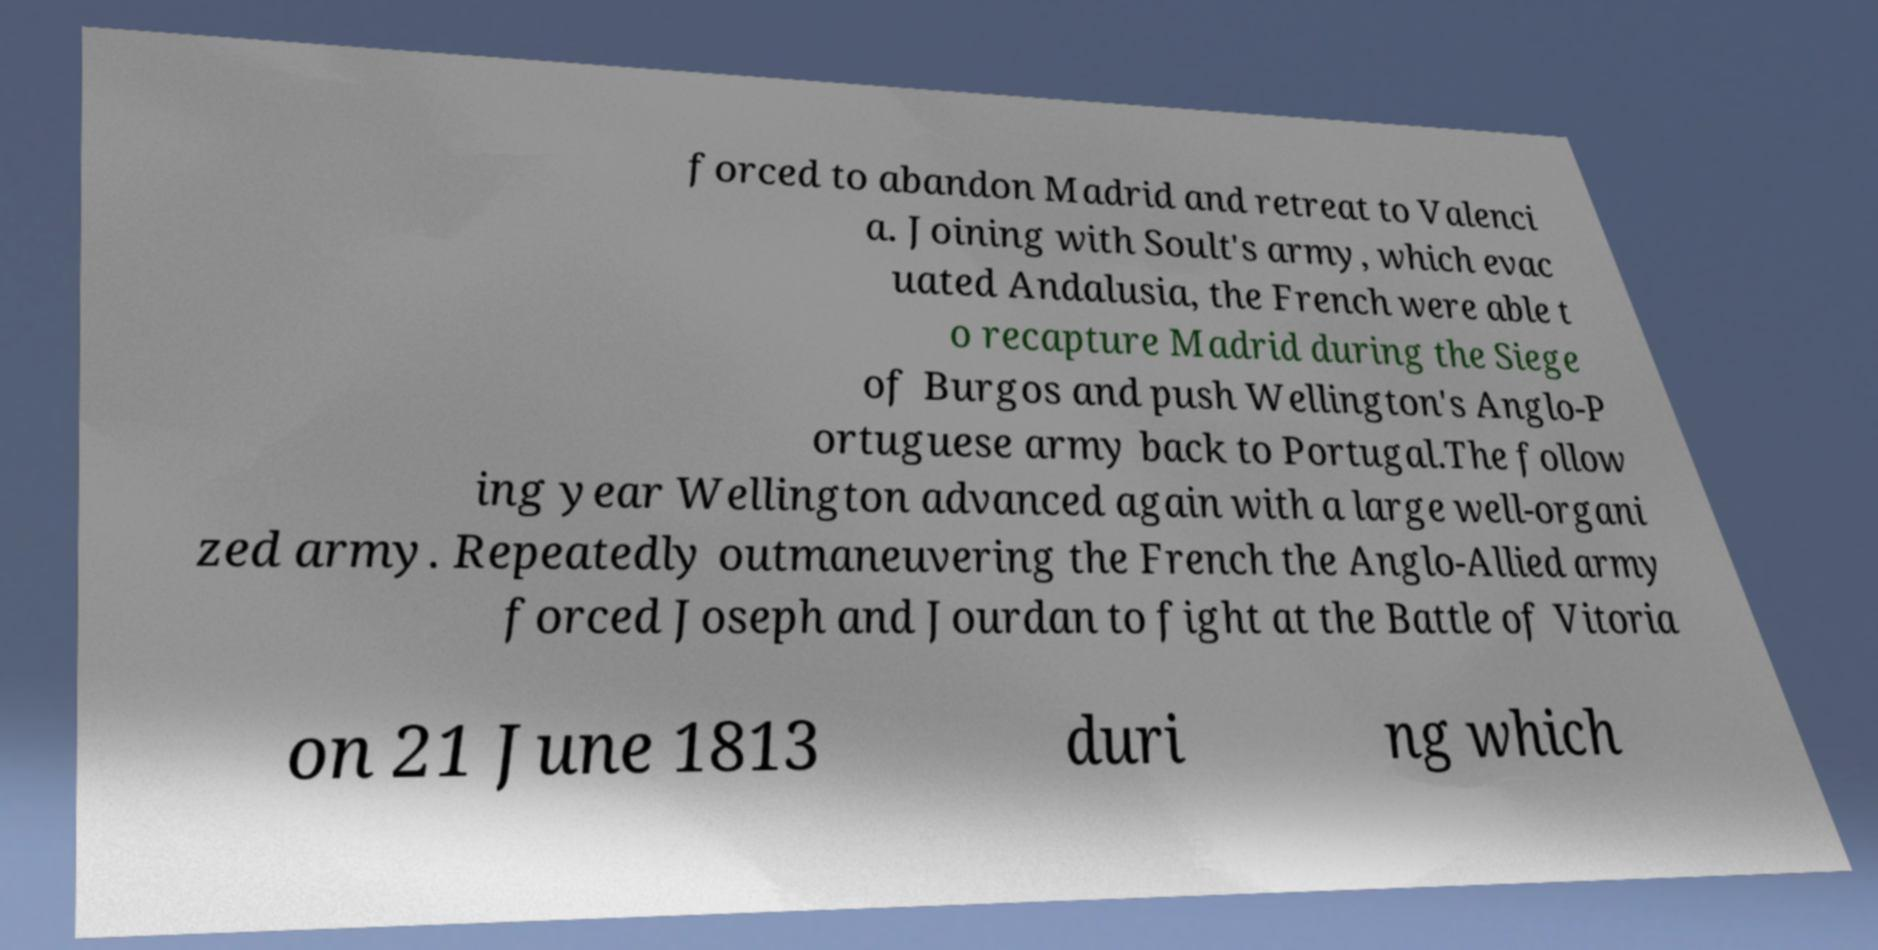Can you read and provide the text displayed in the image?This photo seems to have some interesting text. Can you extract and type it out for me? forced to abandon Madrid and retreat to Valenci a. Joining with Soult's army, which evac uated Andalusia, the French were able t o recapture Madrid during the Siege of Burgos and push Wellington's Anglo-P ortuguese army back to Portugal.The follow ing year Wellington advanced again with a large well-organi zed army. Repeatedly outmaneuvering the French the Anglo-Allied army forced Joseph and Jourdan to fight at the Battle of Vitoria on 21 June 1813 duri ng which 